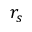<formula> <loc_0><loc_0><loc_500><loc_500>r _ { s }</formula> 